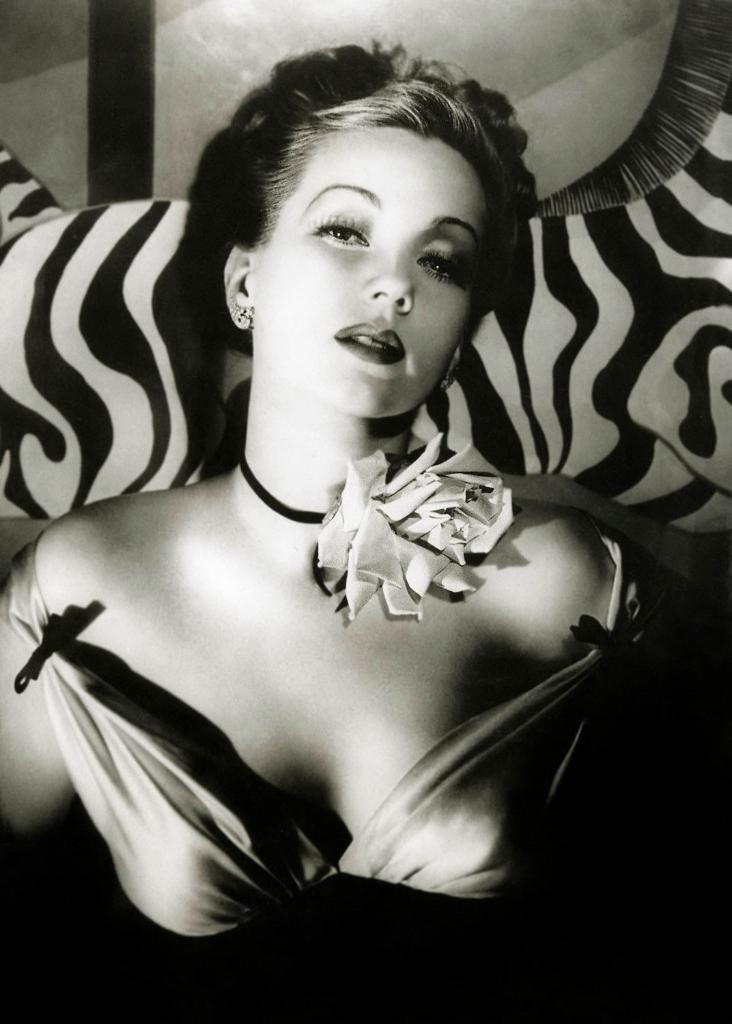Who is present in the image? There is a person in the image. What is the person wearing? The person is wearing a dress. What is the color scheme of the image? The image is black and white. What can be seen in the background of the image? There is an object in the background of the image. How does the person's behavior change throughout the image? The image is a still photograph, so there is no change in the person's behavior. What emotions can be seen on the person's face in the image? The image is black and white, and the person's face is not clearly visible, so it is difficult to determine their emotions. 